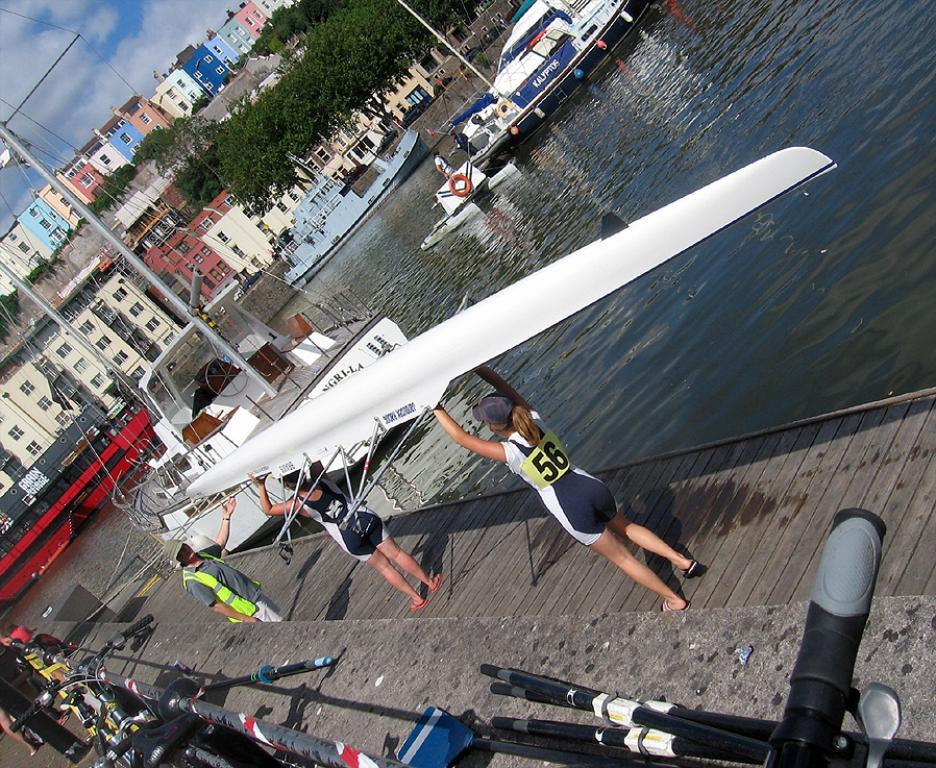<image>
Offer a succinct explanation of the picture presented. A woman holding a kayak is wearing a shirt that says 56 on it. 